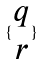Convert formula to latex. <formula><loc_0><loc_0><loc_500><loc_500>\{ \begin{matrix} q \\ r \end{matrix} \}</formula> 